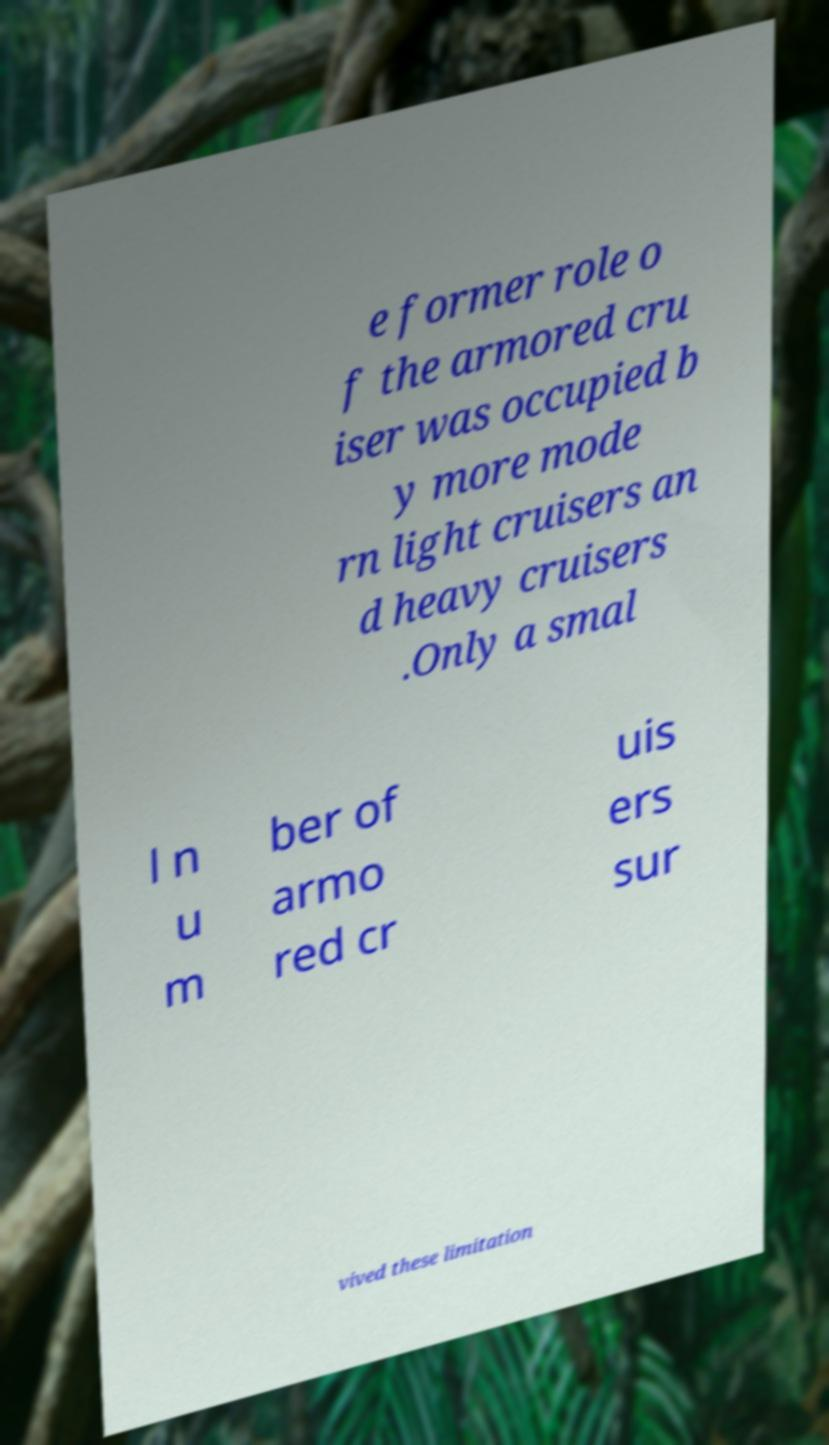What messages or text are displayed in this image? I need them in a readable, typed format. e former role o f the armored cru iser was occupied b y more mode rn light cruisers an d heavy cruisers .Only a smal l n u m ber of armo red cr uis ers sur vived these limitation 